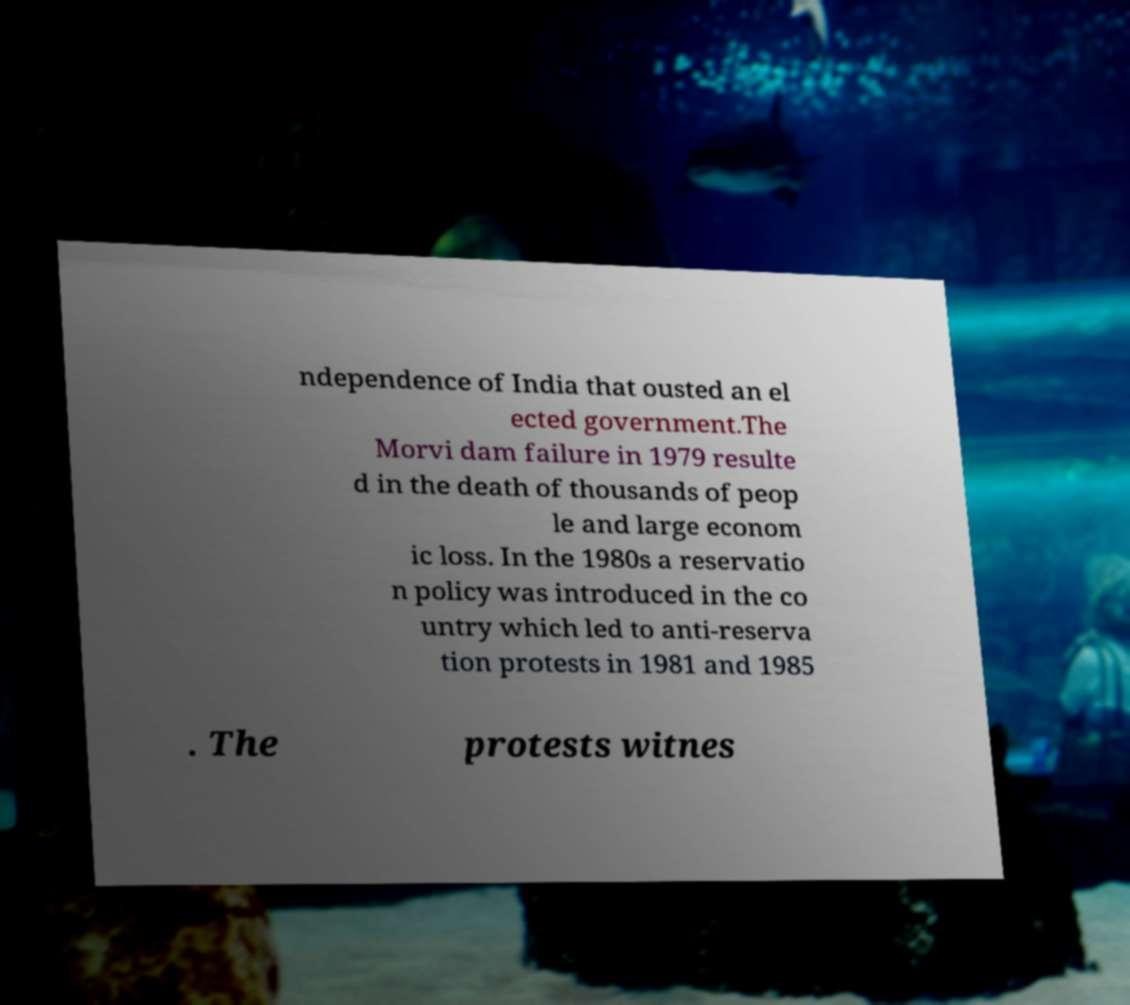What messages or text are displayed in this image? I need them in a readable, typed format. ndependence of India that ousted an el ected government.The Morvi dam failure in 1979 resulte d in the death of thousands of peop le and large econom ic loss. In the 1980s a reservatio n policy was introduced in the co untry which led to anti-reserva tion protests in 1981 and 1985 . The protests witnes 